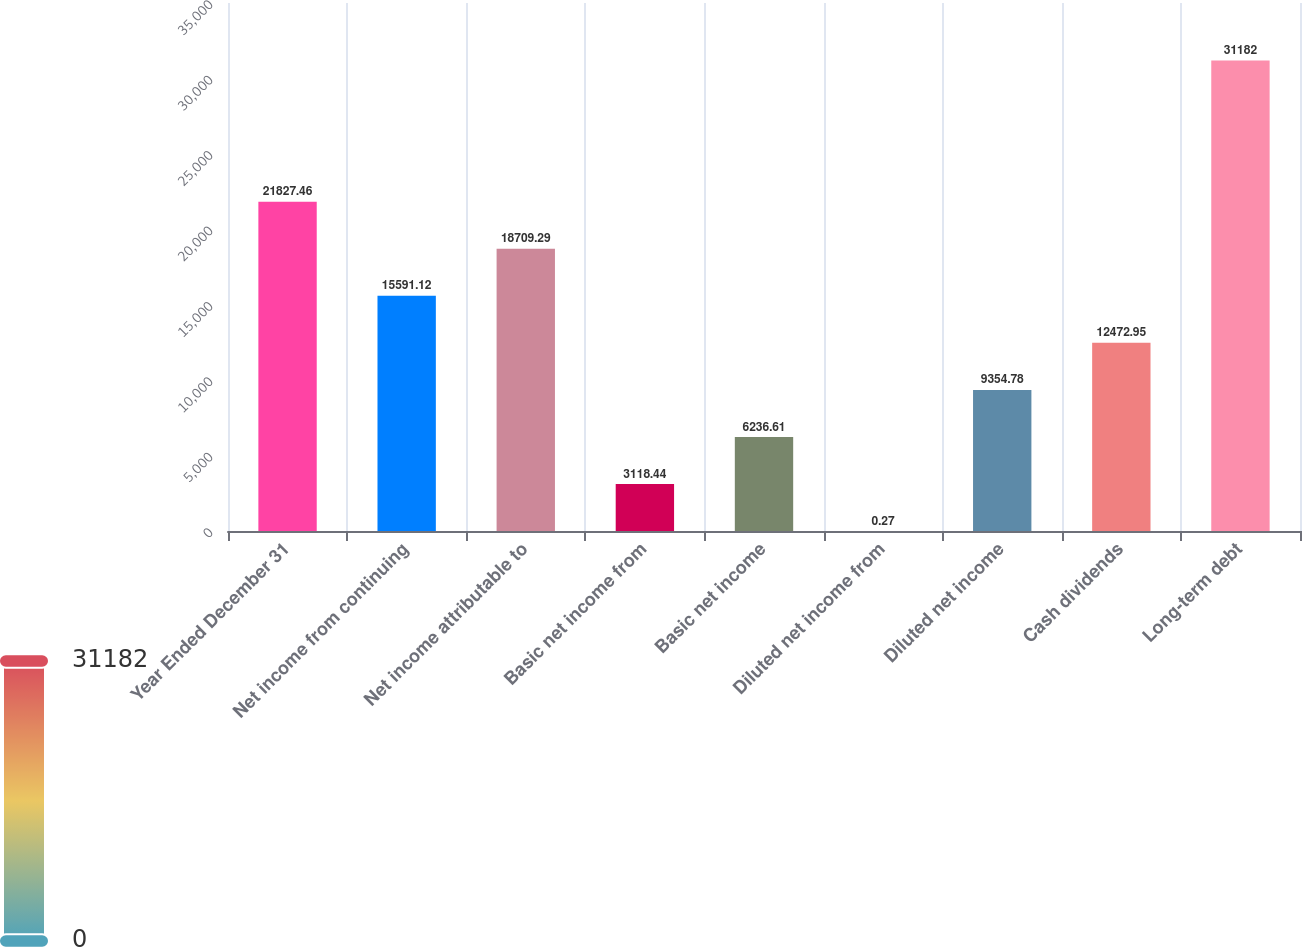<chart> <loc_0><loc_0><loc_500><loc_500><bar_chart><fcel>Year Ended December 31<fcel>Net income from continuing<fcel>Net income attributable to<fcel>Basic net income from<fcel>Basic net income<fcel>Diluted net income from<fcel>Diluted net income<fcel>Cash dividends<fcel>Long-term debt<nl><fcel>21827.5<fcel>15591.1<fcel>18709.3<fcel>3118.44<fcel>6236.61<fcel>0.27<fcel>9354.78<fcel>12473<fcel>31182<nl></chart> 